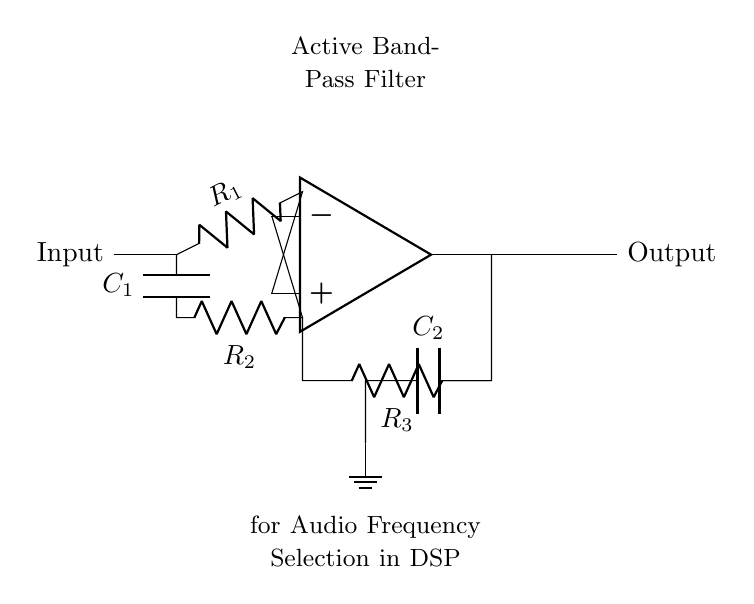What type of filter is shown in the circuit? The circuit is labeled as an "Active Band-Pass Filter," indicating that it is designed to allow frequencies within a certain range to pass while attenuating frequencies outside that range.
Answer: Active Band-Pass Filter What are the resistor values used in this circuit? The circuit specifies three resistors: R1, R2, and R3, but does not provide specific numeric values. Their values need to be determined from additional context or specifications.
Answer: R1, R2, R3 How many capacitors are in the circuit? The circuit contains two capacitors labeled as C1 and C2, indicating their presence and roles in filtering.
Answer: 2 What is the purpose of the op-amp in this filter? The operational amplifier (op-amp) amplifies the input signal and contributes to the overall gain of the filter, which is essential for active filters to achieve desired frequency characteristics.
Answer: Amplification Which components are part of the feedback network? The feedback network includes R2 and C1, which together determine the frequency response and define how the output is fed back to the inverting input of the op-amp.
Answer: R2, C1 What type of signal does this filter mainly target? This active band-pass filter is designed for audio frequency selection, which typically refers to signals in the audible range from approximately 20 Hz to 20 kHz.
Answer: Audio Frequency What effect does the capacitor C2 have in this circuit? Capacitor C2 is likely used for coupling or decoupling purposes, filtering out DC components of the signal at the output and allowing only the AC component to pass through, which is typical in audio applications.
Answer: Coupling 